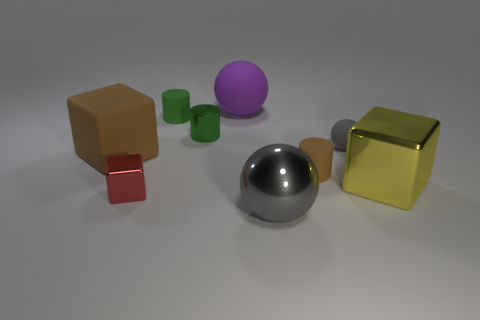Subtract all big blocks. How many blocks are left? 1 Subtract 1 blocks. How many blocks are left? 2 Add 1 shiny cylinders. How many objects exist? 10 Subtract all spheres. How many objects are left? 6 Add 5 green matte objects. How many green matte objects are left? 6 Add 1 big blue spheres. How many big blue spheres exist? 1 Subtract 0 cyan spheres. How many objects are left? 9 Subtract all large blue rubber cylinders. Subtract all brown objects. How many objects are left? 7 